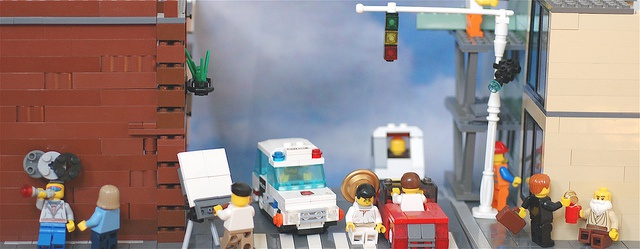Describe the objects in this image and their specific colors. I can see truck in salmon, white, darkgray, teal, and black tones and traffic light in salmon, maroon, black, olive, and darkgreen tones in this image. 